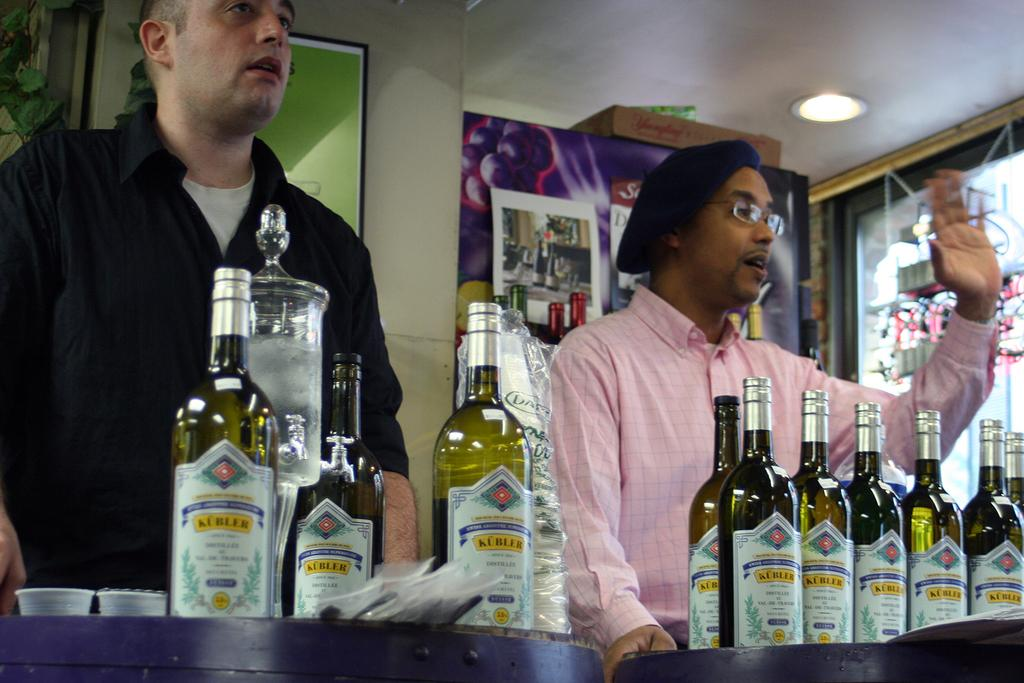How many people are in the image? There are two men in the image. What are the men doing in the image? The men are standing. What can be seen on the table in the background? There are bottles on a table in the background. What is attached to the wall in the background? There is a frame attached to a wall in the background. What is the source of light in the image? There is a light at the top of the image. What type of apparatus is being used by the men in the image? There is no apparatus visible in the image; the men are simply standing. Can you tell me what prose is being recited by the men in the image? There is no indication in the image that the men are reciting any prose or engaging in any verbal communication. 